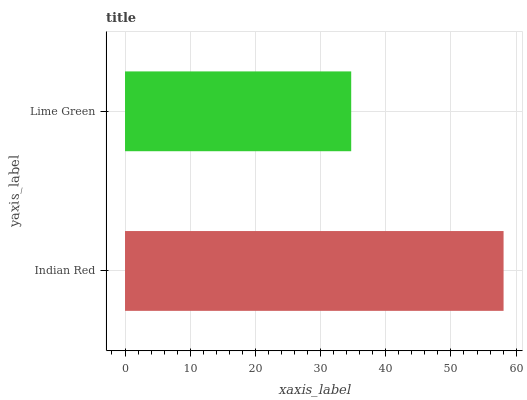Is Lime Green the minimum?
Answer yes or no. Yes. Is Indian Red the maximum?
Answer yes or no. Yes. Is Lime Green the maximum?
Answer yes or no. No. Is Indian Red greater than Lime Green?
Answer yes or no. Yes. Is Lime Green less than Indian Red?
Answer yes or no. Yes. Is Lime Green greater than Indian Red?
Answer yes or no. No. Is Indian Red less than Lime Green?
Answer yes or no. No. Is Indian Red the high median?
Answer yes or no. Yes. Is Lime Green the low median?
Answer yes or no. Yes. Is Lime Green the high median?
Answer yes or no. No. Is Indian Red the low median?
Answer yes or no. No. 